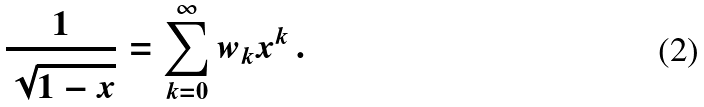<formula> <loc_0><loc_0><loc_500><loc_500>\frac { 1 } { \sqrt { 1 - x } } = \sum _ { k = 0 } ^ { \infty } w _ { k } x ^ { k } \, .</formula> 